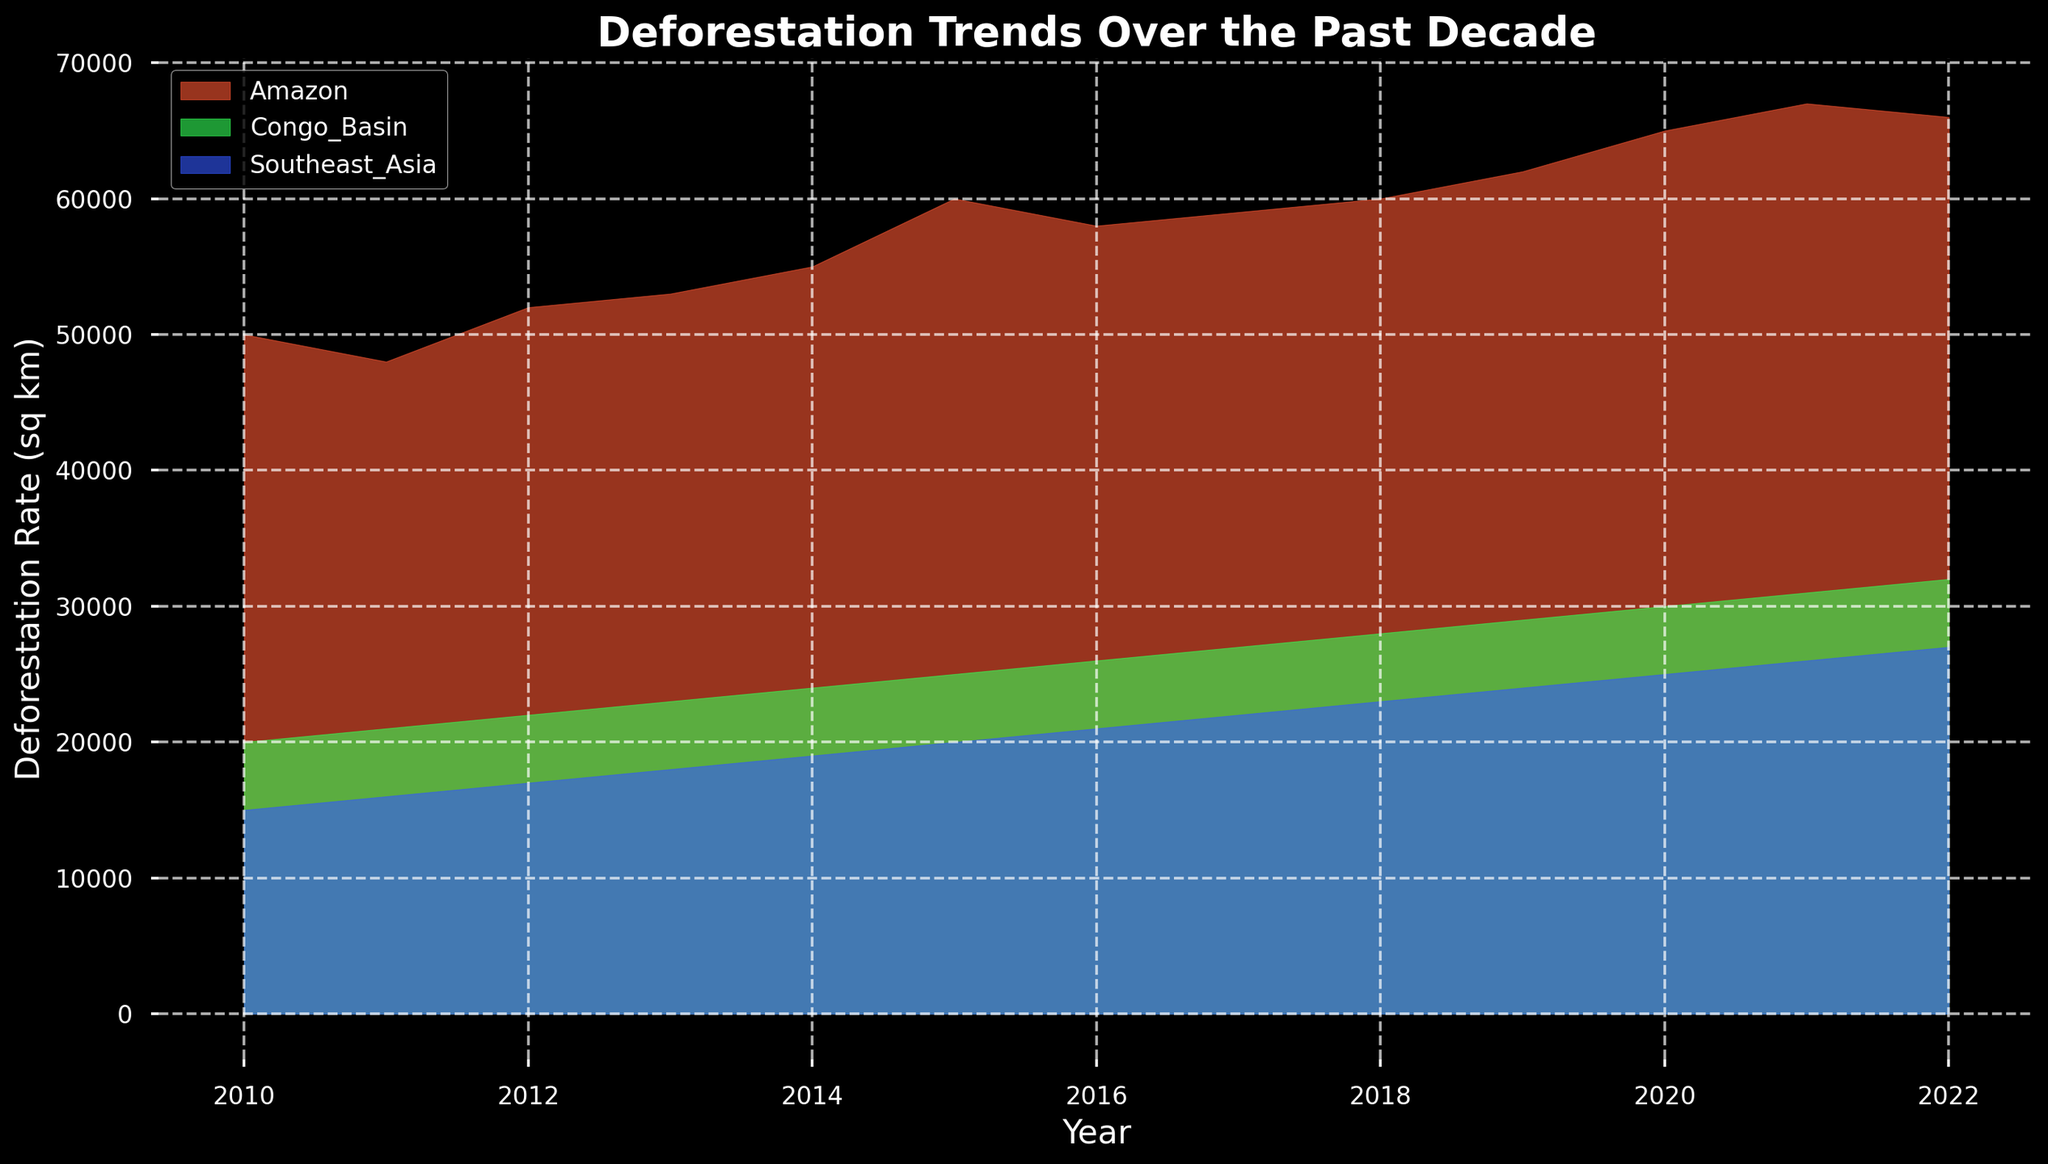What are the general trends in deforestation rates over the past decade for the Amazon region? From the chart, observe that the deforestation rate in the Amazon region generally increased from 2010 to 2022. The rate started around 50,000 sq km in 2010, peaked around 67,000 sq km in 2021, and slightly decreased to 66,000 sq km in 2022.
Answer: Increasing How does the deforestation rate in Southeast Asia in 2016 compare to that in the Congo Basin in the same year? Identify the regions and years in question. The chart shows Southeast Asia with a deforestation rate of 21,000 sq km in 2016. The Congo Basin had a rate of 26,000 sq km the same year. Comparing the two, the Congo Basin had a higher rate than Southeast Asia.
Answer: Congo Basin During which year did the Amazon region have the highest rate of deforestation? Look through the chart for the Amazon region. The highest deforestation rate, approximately 67,000 sq km, is observed in 2021.
Answer: 2021 What is the difference in deforestation rates between the Congo Basin and Southeast Asia in 2022? From the chart, the Congo Basin’s deforestation rate in 2022 is 32,000 sq km and Southeast Asia's is 27,000 sq km. The difference is calculated as 32,000 - 27,000 = 5,000 sq km.
Answer: 5,000 sq km Compare the trends in deforestation rates between Southeast Asia and the Congo Basin from 2010 to 2022. Observe the lines for both regions from 2010 to 2022. Both regions show increasing trends, but the Congo Basin consistently has higher deforestation rates than Southeast Asia. The gap between their rates also widens slightly over this period.
Answer: Congo Basin increasing faster How does the industrial activity index in the Amazon region in 2020 correlate with the deforestation rate in the same year? Locate the Amazon region in 2020; the deforestation rate is around 65,000 sq km while the industrial activity index is 100. A general positive correlation is observed, indicating higher industrial activity aligns with increased deforestation.
Answer: Positively correlated Describe the pattern of deforestation in the Congo Basin from 2010 to 2022. Analyzing the chart, the deforestation rate in the Congo Basin shows a steady upward trend, starting from 20,000 sq km in 2010 and reaching 32,000 sq km in 2022 without significant drops or fluctuations.
Answer: Steady increase What are the cumulative deforestation rates for the Amazon region from 2010 to 2012? Calculate the sum of deforestation rates for the Amazon region from 2010 to 2012: 50,000 + 48,000 + 52,000 sq km = 150,000 sq km.
Answer: 150,000 sq km Which region experienced the most rapid increase in deforestation rates over the decade? Identify the slopes of the lines for each region over the decade. The Amazon shows the most rapid increase, with a significant slope from approximately 50,000 sq km to over 66,000 sq km.
Answer: Amazon 